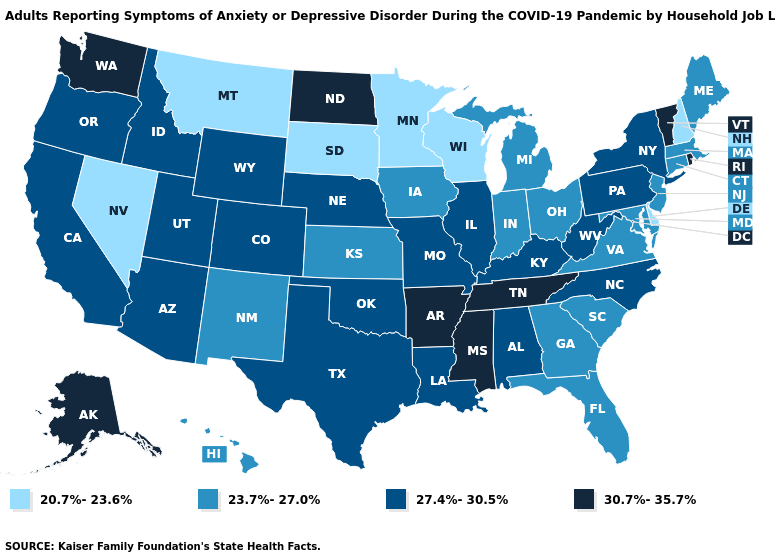Does North Dakota have the highest value in the MidWest?
Short answer required. Yes. What is the value of Delaware?
Concise answer only. 20.7%-23.6%. Does Wisconsin have a lower value than Minnesota?
Short answer required. No. Among the states that border Indiana , which have the lowest value?
Concise answer only. Michigan, Ohio. Does Alabama have the lowest value in the USA?
Quick response, please. No. Name the states that have a value in the range 27.4%-30.5%?
Answer briefly. Alabama, Arizona, California, Colorado, Idaho, Illinois, Kentucky, Louisiana, Missouri, Nebraska, New York, North Carolina, Oklahoma, Oregon, Pennsylvania, Texas, Utah, West Virginia, Wyoming. Does Nevada have the lowest value in the USA?
Keep it brief. Yes. What is the value of Alaska?
Give a very brief answer. 30.7%-35.7%. What is the value of New Jersey?
Short answer required. 23.7%-27.0%. What is the value of Delaware?
Short answer required. 20.7%-23.6%. What is the lowest value in the USA?
Write a very short answer. 20.7%-23.6%. Name the states that have a value in the range 20.7%-23.6%?
Answer briefly. Delaware, Minnesota, Montana, Nevada, New Hampshire, South Dakota, Wisconsin. What is the value of Oregon?
Keep it brief. 27.4%-30.5%. Which states hav the highest value in the MidWest?
Keep it brief. North Dakota. Among the states that border Kansas , which have the highest value?
Short answer required. Colorado, Missouri, Nebraska, Oklahoma. 